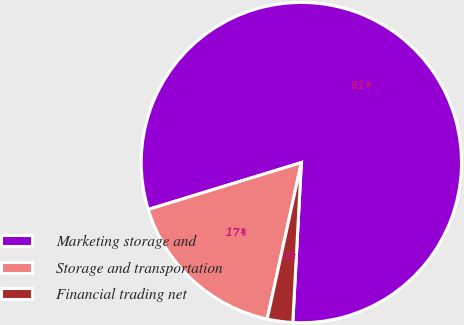<chart> <loc_0><loc_0><loc_500><loc_500><pie_chart><fcel>Marketing storage and<fcel>Storage and transportation<fcel>Financial trading net<nl><fcel>80.59%<fcel>16.85%<fcel>2.57%<nl></chart> 